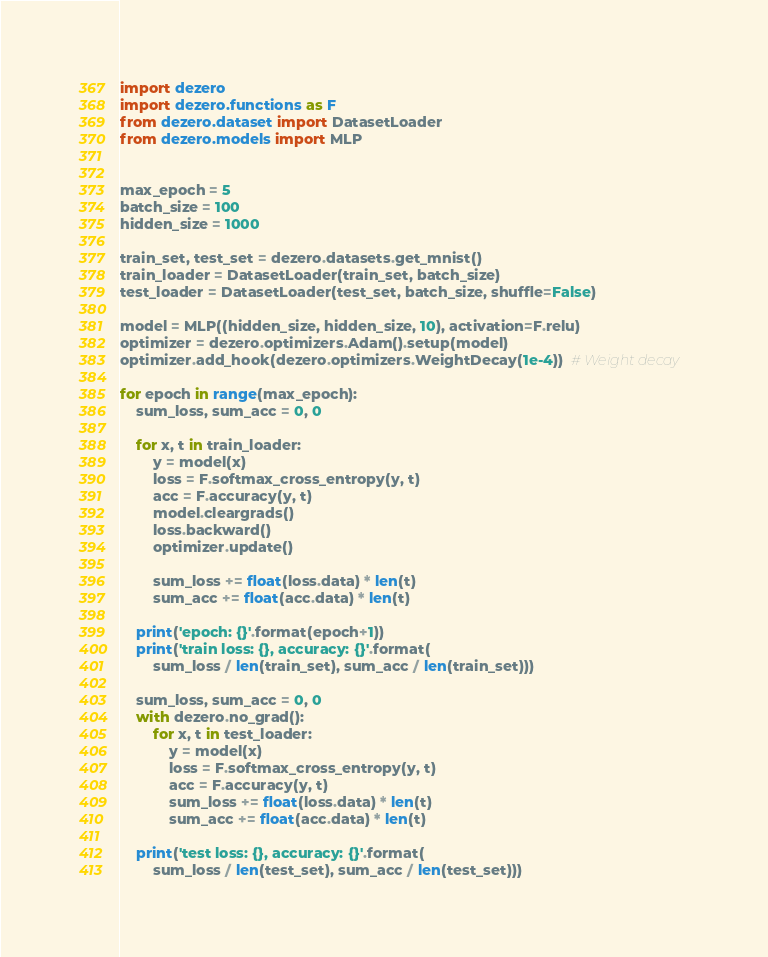Convert code to text. <code><loc_0><loc_0><loc_500><loc_500><_Python_>import dezero
import dezero.functions as F
from dezero.dataset import DatasetLoader
from dezero.models import MLP


max_epoch = 5
batch_size = 100
hidden_size = 1000

train_set, test_set = dezero.datasets.get_mnist()
train_loader = DatasetLoader(train_set, batch_size)
test_loader = DatasetLoader(test_set, batch_size, shuffle=False)

model = MLP((hidden_size, hidden_size, 10), activation=F.relu)
optimizer = dezero.optimizers.Adam().setup(model)
optimizer.add_hook(dezero.optimizers.WeightDecay(1e-4))  # Weight decay

for epoch in range(max_epoch):
    sum_loss, sum_acc = 0, 0

    for x, t in train_loader:
        y = model(x)
        loss = F.softmax_cross_entropy(y, t)
        acc = F.accuracy(y, t)
        model.cleargrads()
        loss.backward()
        optimizer.update()

        sum_loss += float(loss.data) * len(t)
        sum_acc += float(acc.data) * len(t)

    print('epoch: {}'.format(epoch+1))
    print('train loss: {}, accuracy: {}'.format(
        sum_loss / len(train_set), sum_acc / len(train_set)))

    sum_loss, sum_acc = 0, 0
    with dezero.no_grad():
        for x, t in test_loader:
            y = model(x)
            loss = F.softmax_cross_entropy(y, t)
            acc = F.accuracy(y, t)
            sum_loss += float(loss.data) * len(t)
            sum_acc += float(acc.data) * len(t)

    print('test loss: {}, accuracy: {}'.format(
        sum_loss / len(test_set), sum_acc / len(test_set)))</code> 